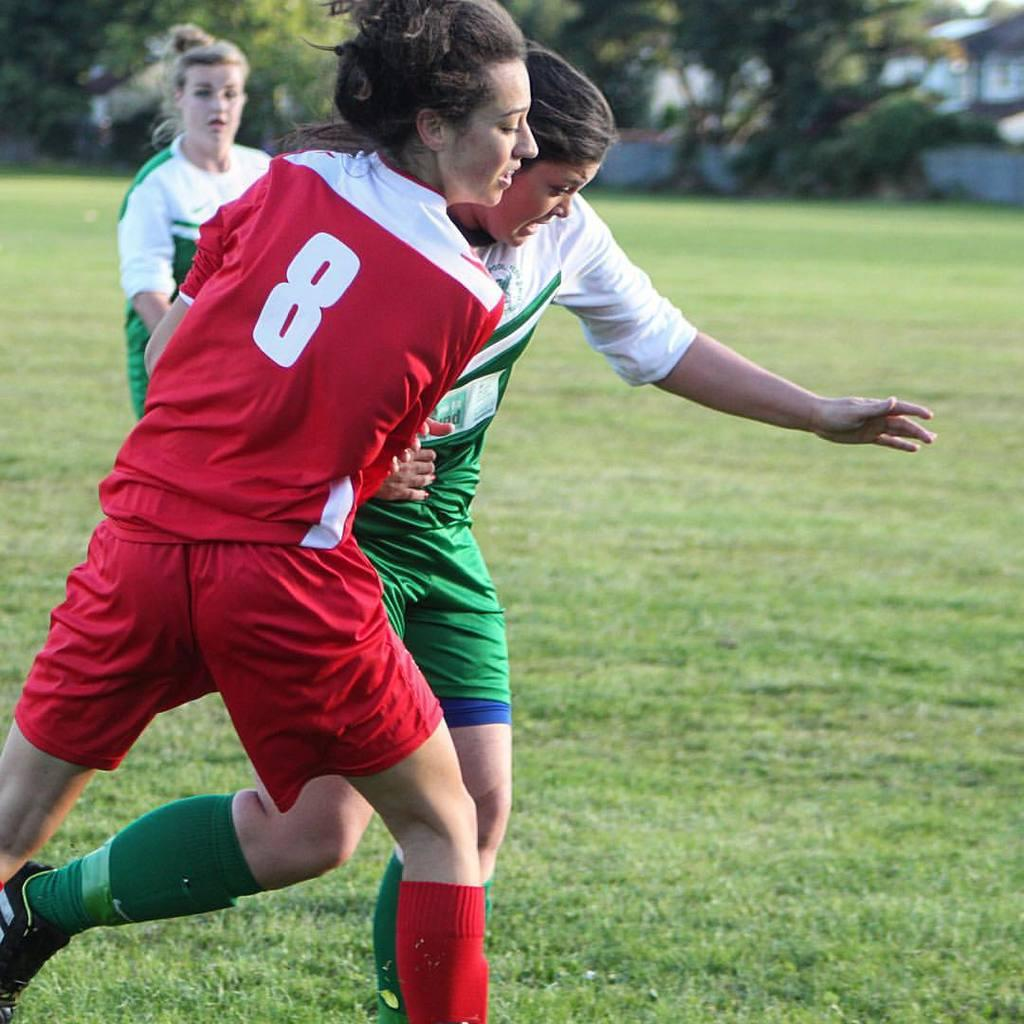Provide a one-sentence caption for the provided image. Two girls battle on a soccer field, one of whom wears the number 8. 